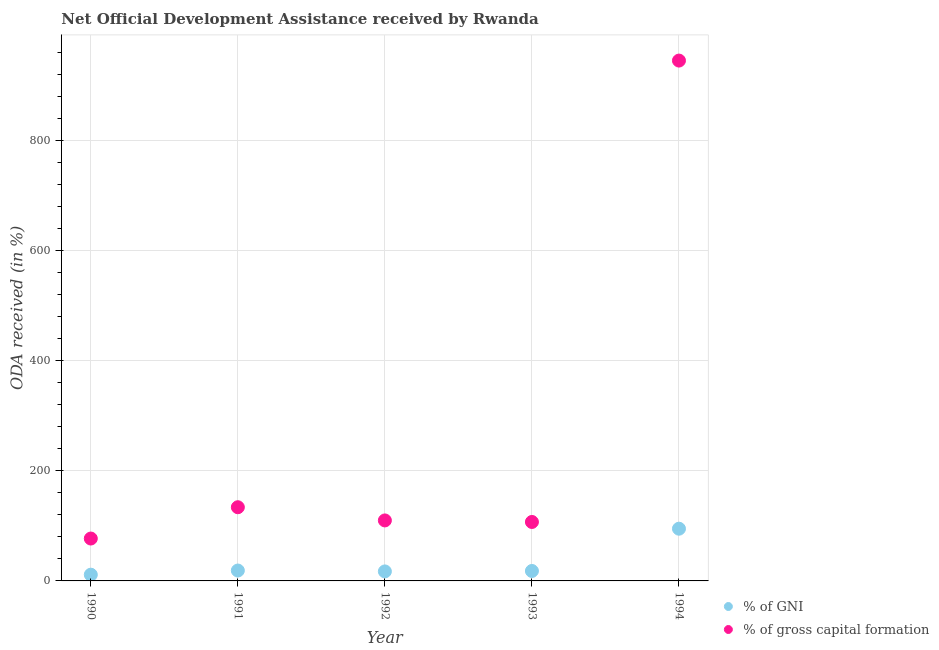How many different coloured dotlines are there?
Keep it short and to the point. 2. What is the oda received as percentage of gross capital formation in 1993?
Make the answer very short. 107.19. Across all years, what is the maximum oda received as percentage of gni?
Keep it short and to the point. 94.95. Across all years, what is the minimum oda received as percentage of gross capital formation?
Ensure brevity in your answer.  77.07. In which year was the oda received as percentage of gross capital formation minimum?
Provide a succinct answer. 1990. What is the total oda received as percentage of gni in the graph?
Offer a very short reply. 160.56. What is the difference between the oda received as percentage of gni in 1990 and that in 1993?
Offer a very short reply. -6.75. What is the difference between the oda received as percentage of gni in 1993 and the oda received as percentage of gross capital formation in 1991?
Make the answer very short. -115.9. What is the average oda received as percentage of gross capital formation per year?
Your answer should be compact. 274.86. In the year 1990, what is the difference between the oda received as percentage of gross capital formation and oda received as percentage of gni?
Your response must be concise. 65.72. What is the ratio of the oda received as percentage of gross capital formation in 1990 to that in 1994?
Give a very brief answer. 0.08. Is the oda received as percentage of gni in 1991 less than that in 1992?
Your answer should be compact. No. Is the difference between the oda received as percentage of gross capital formation in 1990 and 1994 greater than the difference between the oda received as percentage of gni in 1990 and 1994?
Your response must be concise. No. What is the difference between the highest and the second highest oda received as percentage of gross capital formation?
Your answer should be compact. 812.08. What is the difference between the highest and the lowest oda received as percentage of gni?
Keep it short and to the point. 83.6. In how many years, is the oda received as percentage of gross capital formation greater than the average oda received as percentage of gross capital formation taken over all years?
Ensure brevity in your answer.  1. Is the sum of the oda received as percentage of gross capital formation in 1990 and 1992 greater than the maximum oda received as percentage of gni across all years?
Offer a terse response. Yes. Does the oda received as percentage of gross capital formation monotonically increase over the years?
Provide a succinct answer. No. Is the oda received as percentage of gross capital formation strictly greater than the oda received as percentage of gni over the years?
Your response must be concise. Yes. Is the oda received as percentage of gni strictly less than the oda received as percentage of gross capital formation over the years?
Your answer should be very brief. Yes. What is the difference between two consecutive major ticks on the Y-axis?
Offer a very short reply. 200. Does the graph contain any zero values?
Offer a terse response. No. Does the graph contain grids?
Make the answer very short. Yes. Where does the legend appear in the graph?
Give a very brief answer. Bottom right. How many legend labels are there?
Ensure brevity in your answer.  2. What is the title of the graph?
Make the answer very short. Net Official Development Assistance received by Rwanda. What is the label or title of the Y-axis?
Give a very brief answer. ODA received (in %). What is the ODA received (in %) in % of GNI in 1990?
Offer a very short reply. 11.34. What is the ODA received (in %) in % of gross capital formation in 1990?
Your answer should be very brief. 77.07. What is the ODA received (in %) of % of GNI in 1991?
Keep it short and to the point. 18.9. What is the ODA received (in %) in % of gross capital formation in 1991?
Provide a succinct answer. 134. What is the ODA received (in %) of % of GNI in 1992?
Ensure brevity in your answer.  17.28. What is the ODA received (in %) of % of gross capital formation in 1992?
Offer a terse response. 110. What is the ODA received (in %) of % of GNI in 1993?
Your answer should be compact. 18.09. What is the ODA received (in %) of % of gross capital formation in 1993?
Your answer should be compact. 107.19. What is the ODA received (in %) in % of GNI in 1994?
Give a very brief answer. 94.95. What is the ODA received (in %) of % of gross capital formation in 1994?
Offer a very short reply. 946.08. Across all years, what is the maximum ODA received (in %) of % of GNI?
Ensure brevity in your answer.  94.95. Across all years, what is the maximum ODA received (in %) of % of gross capital formation?
Your answer should be very brief. 946.08. Across all years, what is the minimum ODA received (in %) in % of GNI?
Offer a very short reply. 11.34. Across all years, what is the minimum ODA received (in %) in % of gross capital formation?
Make the answer very short. 77.07. What is the total ODA received (in %) of % of GNI in the graph?
Ensure brevity in your answer.  160.56. What is the total ODA received (in %) in % of gross capital formation in the graph?
Provide a short and direct response. 1374.32. What is the difference between the ODA received (in %) of % of GNI in 1990 and that in 1991?
Make the answer very short. -7.55. What is the difference between the ODA received (in %) of % of gross capital formation in 1990 and that in 1991?
Offer a very short reply. -56.93. What is the difference between the ODA received (in %) in % of GNI in 1990 and that in 1992?
Ensure brevity in your answer.  -5.94. What is the difference between the ODA received (in %) of % of gross capital formation in 1990 and that in 1992?
Provide a succinct answer. -32.93. What is the difference between the ODA received (in %) of % of GNI in 1990 and that in 1993?
Your response must be concise. -6.75. What is the difference between the ODA received (in %) of % of gross capital formation in 1990 and that in 1993?
Your answer should be very brief. -30.12. What is the difference between the ODA received (in %) of % of GNI in 1990 and that in 1994?
Offer a terse response. -83.6. What is the difference between the ODA received (in %) in % of gross capital formation in 1990 and that in 1994?
Offer a terse response. -869.01. What is the difference between the ODA received (in %) of % of GNI in 1991 and that in 1992?
Keep it short and to the point. 1.61. What is the difference between the ODA received (in %) in % of gross capital formation in 1991 and that in 1992?
Your answer should be compact. 24. What is the difference between the ODA received (in %) in % of GNI in 1991 and that in 1993?
Offer a very short reply. 0.81. What is the difference between the ODA received (in %) in % of gross capital formation in 1991 and that in 1993?
Your answer should be very brief. 26.81. What is the difference between the ODA received (in %) of % of GNI in 1991 and that in 1994?
Offer a terse response. -76.05. What is the difference between the ODA received (in %) of % of gross capital formation in 1991 and that in 1994?
Your answer should be compact. -812.08. What is the difference between the ODA received (in %) in % of GNI in 1992 and that in 1993?
Give a very brief answer. -0.81. What is the difference between the ODA received (in %) of % of gross capital formation in 1992 and that in 1993?
Your answer should be compact. 2.81. What is the difference between the ODA received (in %) of % of GNI in 1992 and that in 1994?
Give a very brief answer. -77.66. What is the difference between the ODA received (in %) in % of gross capital formation in 1992 and that in 1994?
Give a very brief answer. -836.08. What is the difference between the ODA received (in %) of % of GNI in 1993 and that in 1994?
Keep it short and to the point. -76.86. What is the difference between the ODA received (in %) in % of gross capital formation in 1993 and that in 1994?
Offer a terse response. -838.89. What is the difference between the ODA received (in %) in % of GNI in 1990 and the ODA received (in %) in % of gross capital formation in 1991?
Offer a terse response. -122.65. What is the difference between the ODA received (in %) of % of GNI in 1990 and the ODA received (in %) of % of gross capital formation in 1992?
Offer a terse response. -98.65. What is the difference between the ODA received (in %) in % of GNI in 1990 and the ODA received (in %) in % of gross capital formation in 1993?
Offer a terse response. -95.85. What is the difference between the ODA received (in %) of % of GNI in 1990 and the ODA received (in %) of % of gross capital formation in 1994?
Ensure brevity in your answer.  -934.73. What is the difference between the ODA received (in %) of % of GNI in 1991 and the ODA received (in %) of % of gross capital formation in 1992?
Your answer should be very brief. -91.1. What is the difference between the ODA received (in %) of % of GNI in 1991 and the ODA received (in %) of % of gross capital formation in 1993?
Make the answer very short. -88.29. What is the difference between the ODA received (in %) in % of GNI in 1991 and the ODA received (in %) in % of gross capital formation in 1994?
Keep it short and to the point. -927.18. What is the difference between the ODA received (in %) in % of GNI in 1992 and the ODA received (in %) in % of gross capital formation in 1993?
Provide a short and direct response. -89.91. What is the difference between the ODA received (in %) of % of GNI in 1992 and the ODA received (in %) of % of gross capital formation in 1994?
Your response must be concise. -928.79. What is the difference between the ODA received (in %) of % of GNI in 1993 and the ODA received (in %) of % of gross capital formation in 1994?
Provide a succinct answer. -927.99. What is the average ODA received (in %) of % of GNI per year?
Keep it short and to the point. 32.11. What is the average ODA received (in %) of % of gross capital formation per year?
Make the answer very short. 274.86. In the year 1990, what is the difference between the ODA received (in %) of % of GNI and ODA received (in %) of % of gross capital formation?
Offer a very short reply. -65.72. In the year 1991, what is the difference between the ODA received (in %) in % of GNI and ODA received (in %) in % of gross capital formation?
Keep it short and to the point. -115.1. In the year 1992, what is the difference between the ODA received (in %) in % of GNI and ODA received (in %) in % of gross capital formation?
Keep it short and to the point. -92.71. In the year 1993, what is the difference between the ODA received (in %) in % of GNI and ODA received (in %) in % of gross capital formation?
Give a very brief answer. -89.1. In the year 1994, what is the difference between the ODA received (in %) of % of GNI and ODA received (in %) of % of gross capital formation?
Ensure brevity in your answer.  -851.13. What is the ratio of the ODA received (in %) in % of GNI in 1990 to that in 1991?
Give a very brief answer. 0.6. What is the ratio of the ODA received (in %) in % of gross capital formation in 1990 to that in 1991?
Make the answer very short. 0.58. What is the ratio of the ODA received (in %) of % of GNI in 1990 to that in 1992?
Keep it short and to the point. 0.66. What is the ratio of the ODA received (in %) of % of gross capital formation in 1990 to that in 1992?
Your answer should be compact. 0.7. What is the ratio of the ODA received (in %) in % of GNI in 1990 to that in 1993?
Your answer should be compact. 0.63. What is the ratio of the ODA received (in %) in % of gross capital formation in 1990 to that in 1993?
Offer a terse response. 0.72. What is the ratio of the ODA received (in %) of % of GNI in 1990 to that in 1994?
Make the answer very short. 0.12. What is the ratio of the ODA received (in %) in % of gross capital formation in 1990 to that in 1994?
Offer a terse response. 0.08. What is the ratio of the ODA received (in %) in % of GNI in 1991 to that in 1992?
Your answer should be compact. 1.09. What is the ratio of the ODA received (in %) of % of gross capital formation in 1991 to that in 1992?
Give a very brief answer. 1.22. What is the ratio of the ODA received (in %) of % of GNI in 1991 to that in 1993?
Give a very brief answer. 1.04. What is the ratio of the ODA received (in %) in % of gross capital formation in 1991 to that in 1993?
Provide a succinct answer. 1.25. What is the ratio of the ODA received (in %) of % of GNI in 1991 to that in 1994?
Provide a succinct answer. 0.2. What is the ratio of the ODA received (in %) in % of gross capital formation in 1991 to that in 1994?
Make the answer very short. 0.14. What is the ratio of the ODA received (in %) in % of GNI in 1992 to that in 1993?
Offer a very short reply. 0.96. What is the ratio of the ODA received (in %) in % of gross capital formation in 1992 to that in 1993?
Provide a succinct answer. 1.03. What is the ratio of the ODA received (in %) in % of GNI in 1992 to that in 1994?
Make the answer very short. 0.18. What is the ratio of the ODA received (in %) of % of gross capital formation in 1992 to that in 1994?
Ensure brevity in your answer.  0.12. What is the ratio of the ODA received (in %) in % of GNI in 1993 to that in 1994?
Provide a succinct answer. 0.19. What is the ratio of the ODA received (in %) of % of gross capital formation in 1993 to that in 1994?
Ensure brevity in your answer.  0.11. What is the difference between the highest and the second highest ODA received (in %) of % of GNI?
Your answer should be very brief. 76.05. What is the difference between the highest and the second highest ODA received (in %) in % of gross capital formation?
Ensure brevity in your answer.  812.08. What is the difference between the highest and the lowest ODA received (in %) of % of GNI?
Your response must be concise. 83.6. What is the difference between the highest and the lowest ODA received (in %) of % of gross capital formation?
Provide a short and direct response. 869.01. 